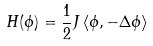Convert formula to latex. <formula><loc_0><loc_0><loc_500><loc_500>H ( \phi ) = \frac { 1 } { 2 } J \left \langle \phi , - \Delta \phi \right \rangle</formula> 